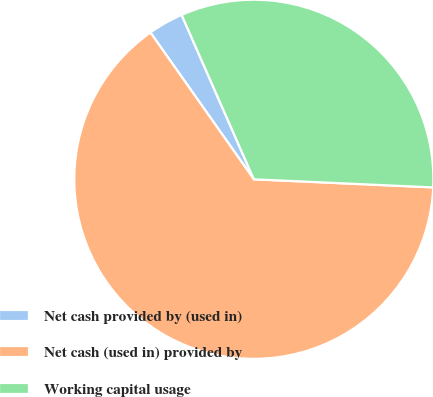<chart> <loc_0><loc_0><loc_500><loc_500><pie_chart><fcel>Net cash provided by (used in)<fcel>Net cash (used in) provided by<fcel>Working capital usage<nl><fcel>3.18%<fcel>64.51%<fcel>32.31%<nl></chart> 